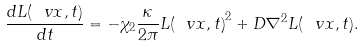Convert formula to latex. <formula><loc_0><loc_0><loc_500><loc_500>\frac { d L ( \ v x , t ) } { d t } = - \chi _ { 2 } \frac { \kappa } { 2 \pi } { L ( \ v x , t ) } ^ { 2 } + D \nabla ^ { 2 } L ( \ v x , t ) .</formula> 